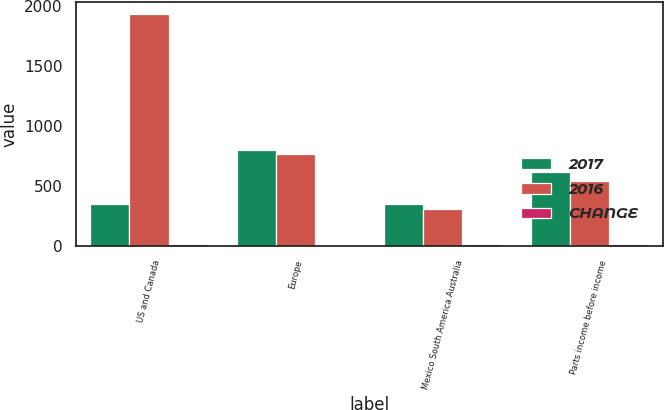Convert chart to OTSL. <chart><loc_0><loc_0><loc_500><loc_500><stacked_bar_chart><ecel><fcel>US and Canada<fcel>Europe<fcel>Mexico South America Australia<fcel>Parts income before income<nl><fcel>2017<fcel>351<fcel>801<fcel>351<fcel>614.2<nl><fcel>2016<fcel>1932.7<fcel>761.8<fcel>311.2<fcel>543.8<nl><fcel>CHANGE<fcel>13<fcel>5<fcel>13<fcel>13<nl></chart> 